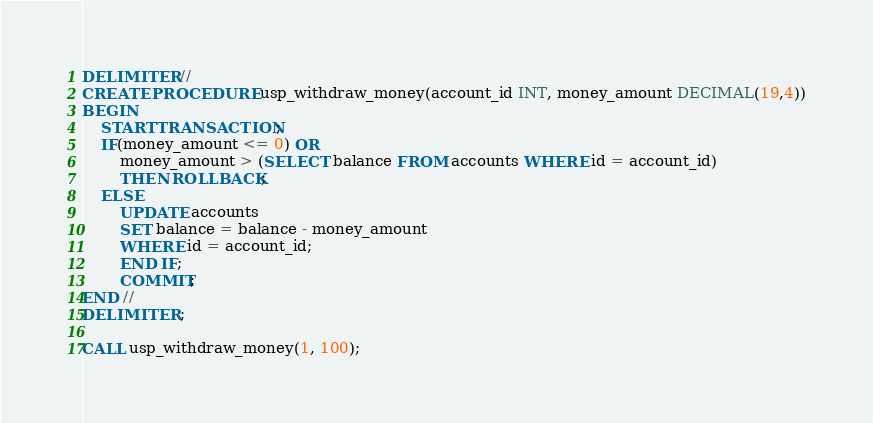<code> <loc_0><loc_0><loc_500><loc_500><_SQL_>DELIMITER //
CREATE PROCEDURE usp_withdraw_money(account_id INT, money_amount DECIMAL(19,4))
BEGIN
	START TRANSACTION;
    IF(money_amount <= 0) OR
		money_amount > (SELECT balance FROM accounts WHERE id = account_id)
		THEN ROLLBACK;
    ELSE
		UPDATE accounts
        SET balance = balance - money_amount
        WHERE id = account_id;
        END IF;
        COMMIT;
END //
DELIMITER ;

CALL usp_withdraw_money(1, 100);</code> 